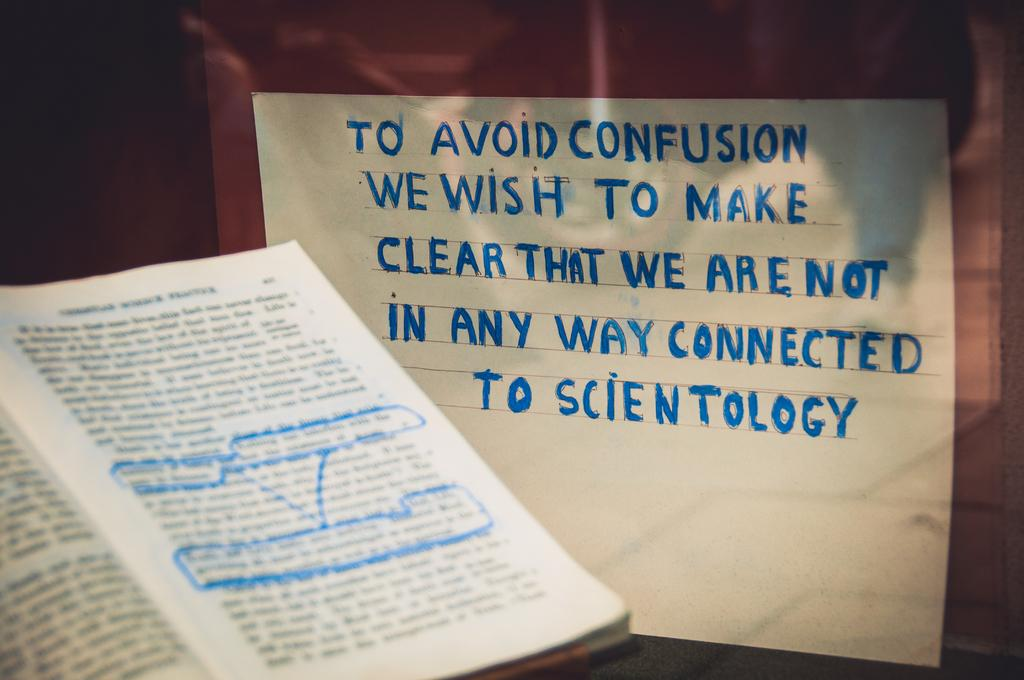<image>
Relay a brief, clear account of the picture shown. A sign proclaims that We wish to make clear that we are not in any way connected to scientology. 